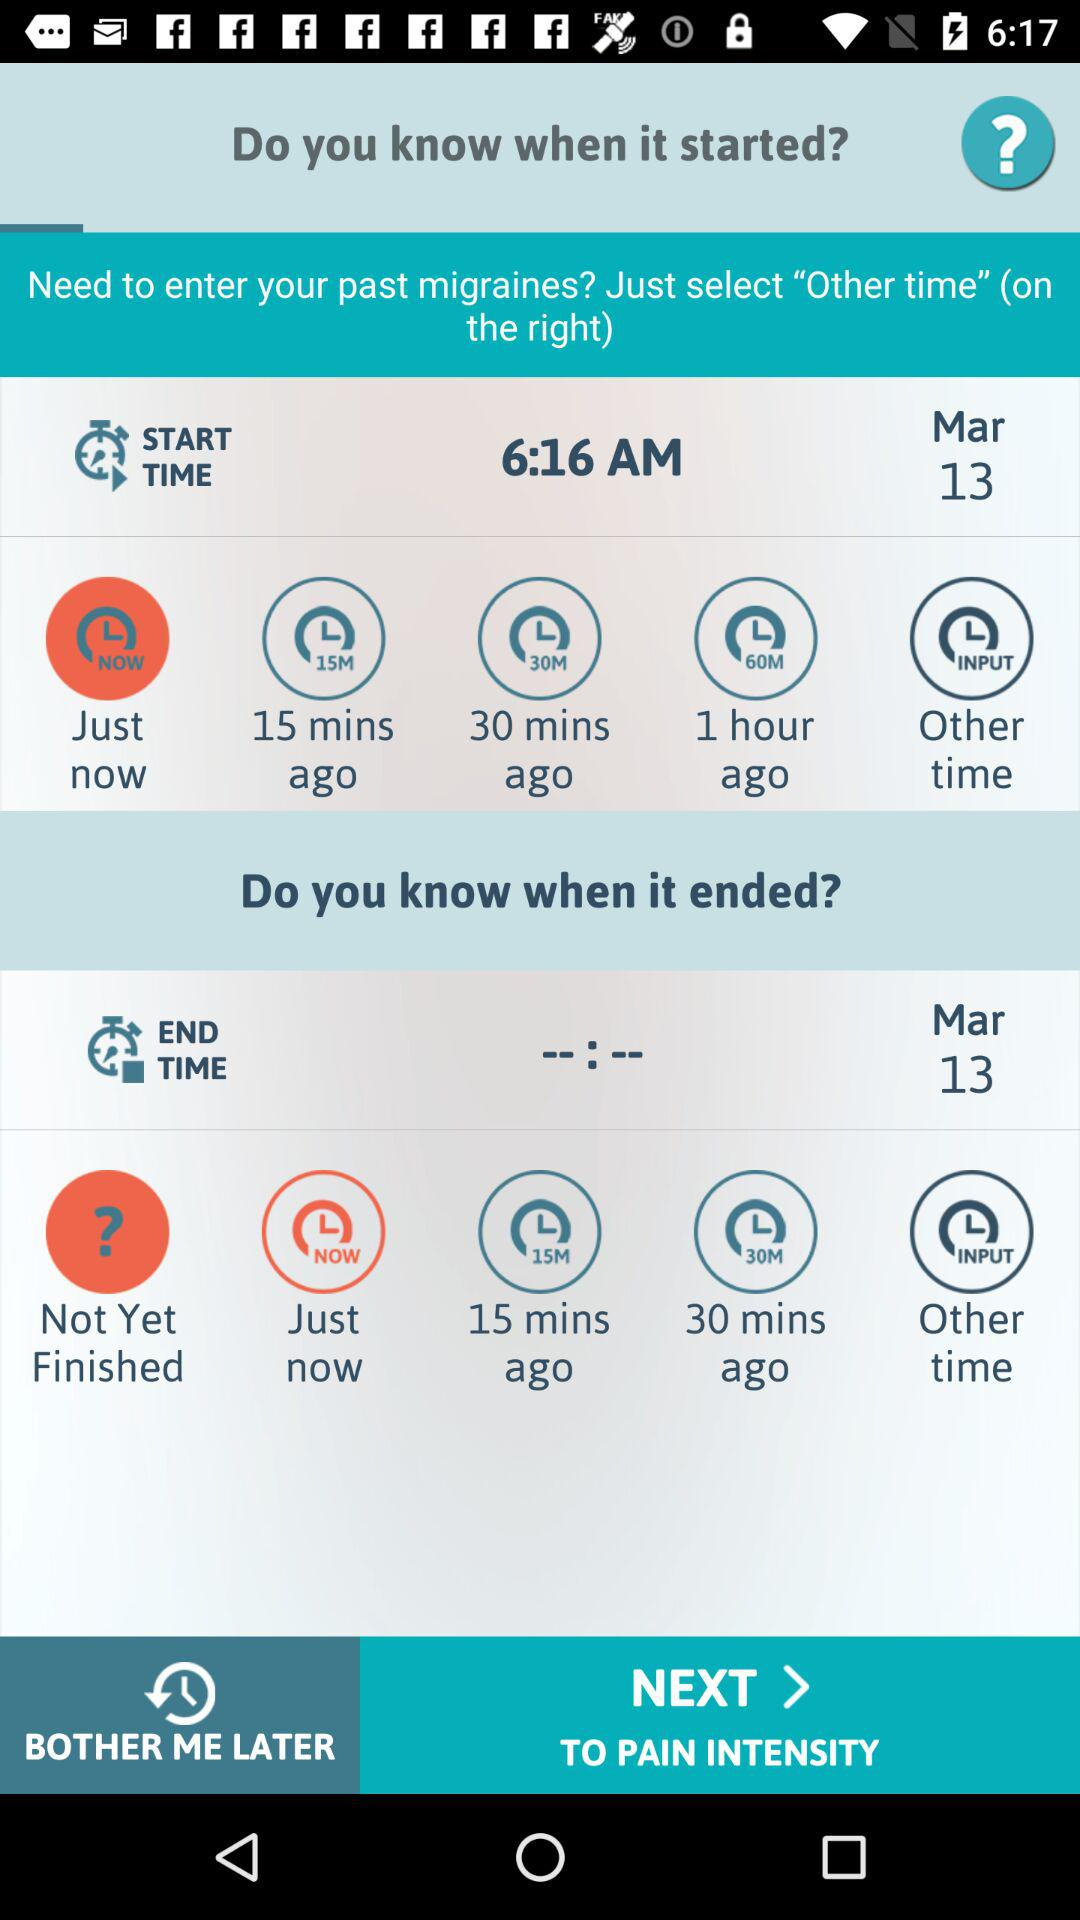How many start times are there to choose from?
Answer the question using a single word or phrase. 5 